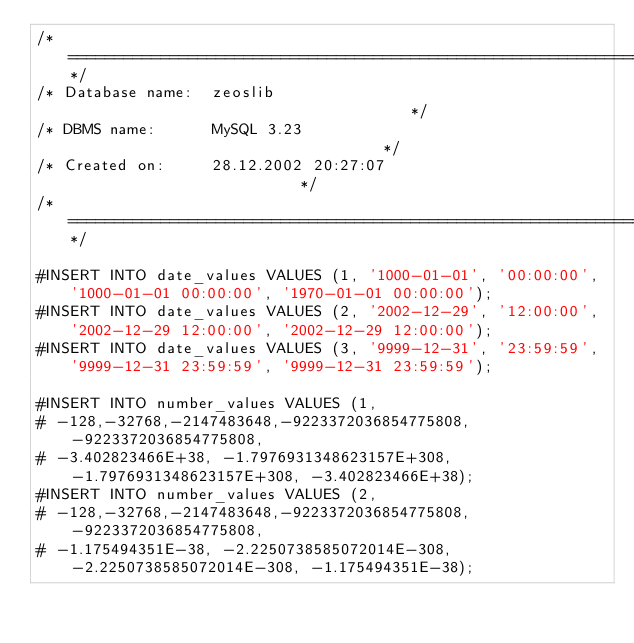Convert code to text. <code><loc_0><loc_0><loc_500><loc_500><_SQL_>/*==============================================================*/
/* Database name:  zeoslib                                      */
/* DBMS name:      MySQL 3.23                                   */
/* Created on:     28.12.2002 20:27:07                          */
/*==============================================================*/

#INSERT INTO date_values VALUES (1, '1000-01-01', '00:00:00', '1000-01-01 00:00:00', '1970-01-01 00:00:00');
#INSERT INTO date_values VALUES (2, '2002-12-29', '12:00:00', '2002-12-29 12:00:00', '2002-12-29 12:00:00');
#INSERT INTO date_values VALUES (3, '9999-12-31', '23:59:59', '9999-12-31 23:59:59', '9999-12-31 23:59:59');

#INSERT INTO number_values VALUES (1,
#	-128,-32768,-2147483648,-9223372036854775808, -9223372036854775808,
#	-3.402823466E+38, -1.7976931348623157E+308, -1.7976931348623157E+308, -3.402823466E+38);
#INSERT INTO number_values VALUES (2,
#	-128,-32768,-2147483648,-9223372036854775808, -9223372036854775808,
#	-1.175494351E-38, -2.2250738585072014E-308, -2.2250738585072014E-308, -1.175494351E-38);</code> 